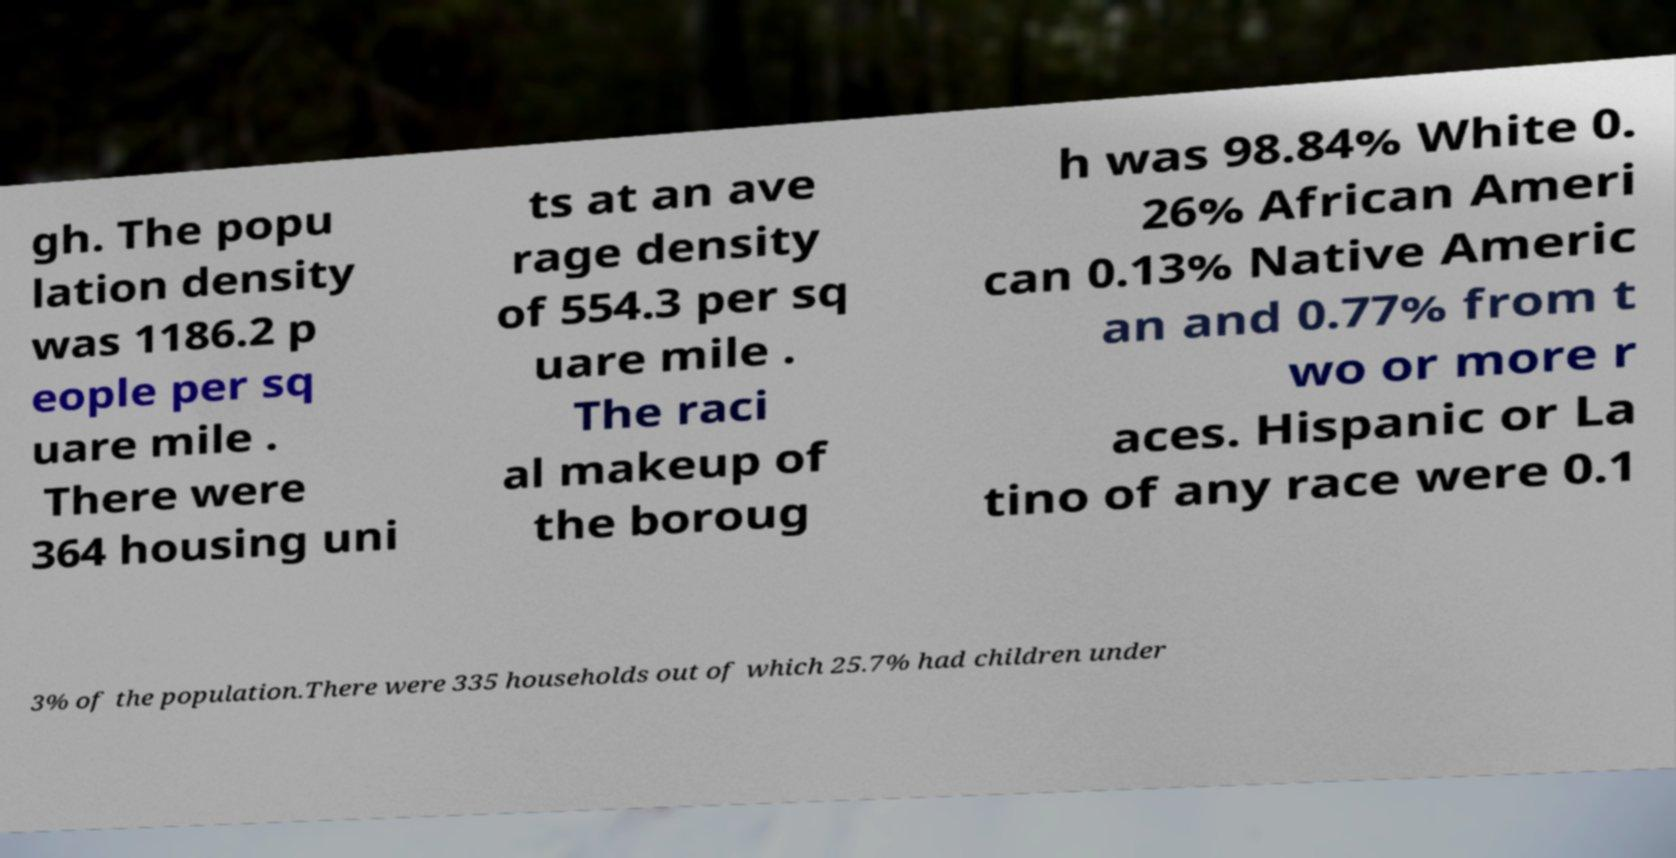Please identify and transcribe the text found in this image. gh. The popu lation density was 1186.2 p eople per sq uare mile . There were 364 housing uni ts at an ave rage density of 554.3 per sq uare mile . The raci al makeup of the boroug h was 98.84% White 0. 26% African Ameri can 0.13% Native Americ an and 0.77% from t wo or more r aces. Hispanic or La tino of any race were 0.1 3% of the population.There were 335 households out of which 25.7% had children under 